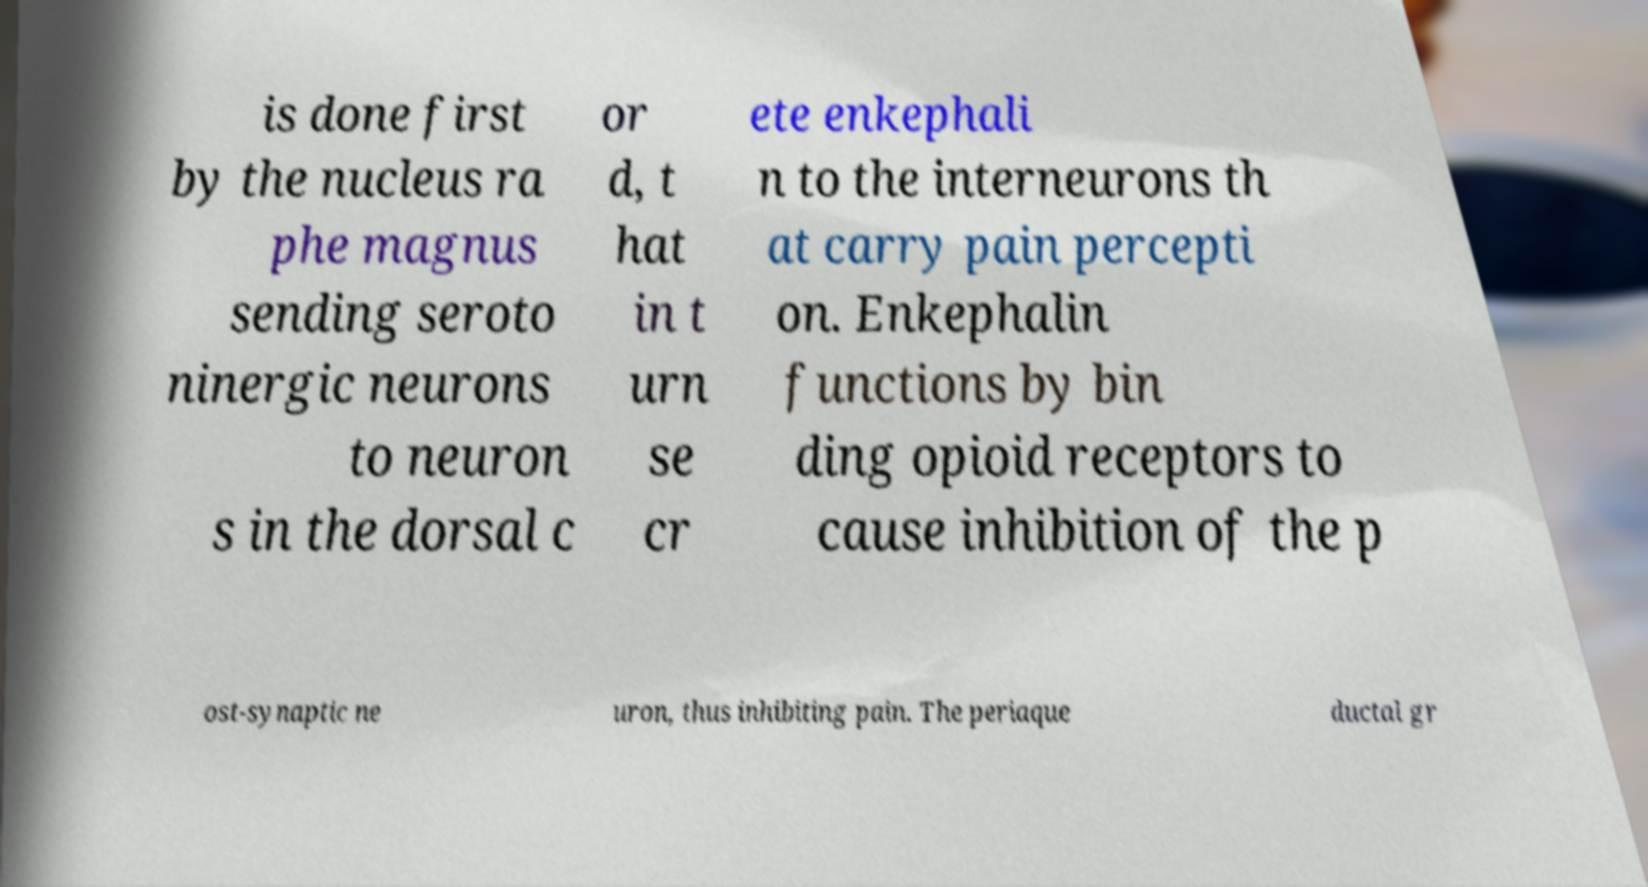What messages or text are displayed in this image? I need them in a readable, typed format. is done first by the nucleus ra phe magnus sending seroto ninergic neurons to neuron s in the dorsal c or d, t hat in t urn se cr ete enkephali n to the interneurons th at carry pain percepti on. Enkephalin functions by bin ding opioid receptors to cause inhibition of the p ost-synaptic ne uron, thus inhibiting pain. The periaque ductal gr 